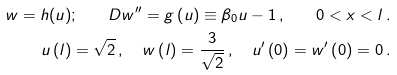<formula> <loc_0><loc_0><loc_500><loc_500>w = h ( u ) ; \quad D w ^ { \prime \prime } = g \left ( u \right ) \equiv \beta _ { 0 } u - 1 \, , \quad 0 < x < l \, . \\ u \left ( l \right ) = \sqrt { 2 } \, , \quad w \left ( l \right ) = \frac { 3 } { \sqrt { 2 } } \, , \quad u ^ { \prime } \left ( 0 \right ) = w ^ { \prime } \left ( 0 \right ) = 0 \, .</formula> 